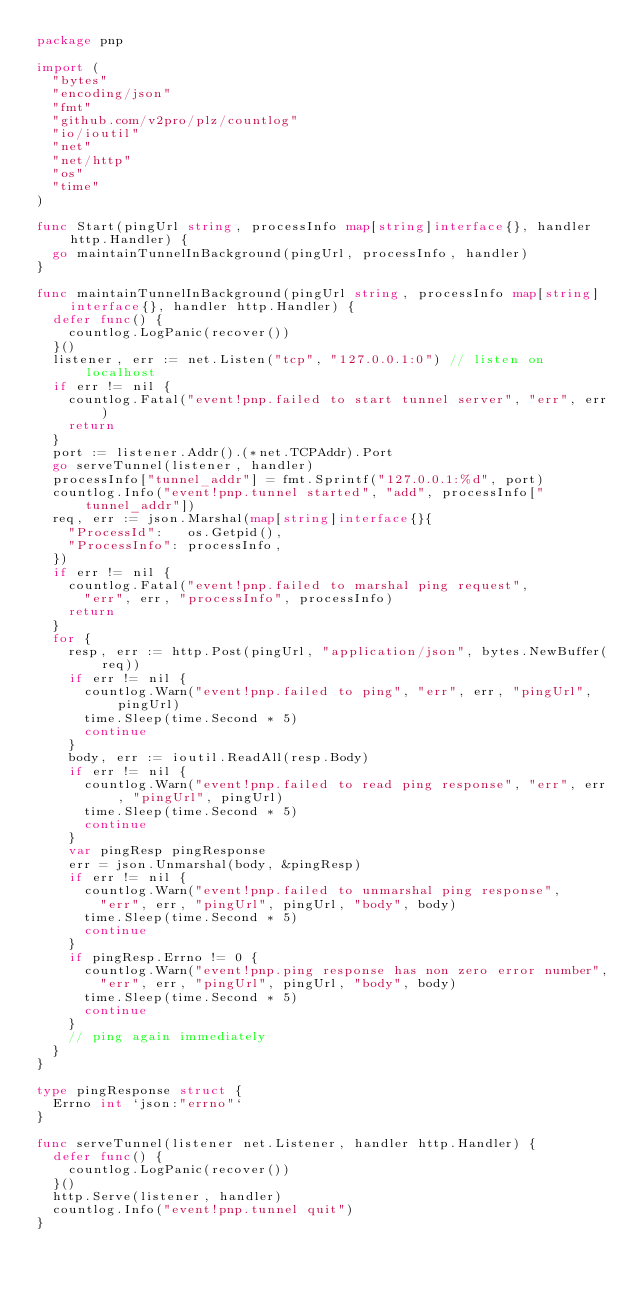Convert code to text. <code><loc_0><loc_0><loc_500><loc_500><_Go_>package pnp

import (
	"bytes"
	"encoding/json"
	"fmt"
	"github.com/v2pro/plz/countlog"
	"io/ioutil"
	"net"
	"net/http"
	"os"
	"time"
)

func Start(pingUrl string, processInfo map[string]interface{}, handler http.Handler) {
	go maintainTunnelInBackground(pingUrl, processInfo, handler)
}

func maintainTunnelInBackground(pingUrl string, processInfo map[string]interface{}, handler http.Handler) {
	defer func() {
		countlog.LogPanic(recover())
	}()
	listener, err := net.Listen("tcp", "127.0.0.1:0") // listen on localhost
	if err != nil {
		countlog.Fatal("event!pnp.failed to start tunnel server", "err", err)
		return
	}
	port := listener.Addr().(*net.TCPAddr).Port
	go serveTunnel(listener, handler)
	processInfo["tunnel_addr"] = fmt.Sprintf("127.0.0.1:%d", port)
	countlog.Info("event!pnp.tunnel started", "add", processInfo["tunnel_addr"])
	req, err := json.Marshal(map[string]interface{}{
		"ProcessId":   os.Getpid(),
		"ProcessInfo": processInfo,
	})
	if err != nil {
		countlog.Fatal("event!pnp.failed to marshal ping request",
			"err", err, "processInfo", processInfo)
		return
	}
	for {
		resp, err := http.Post(pingUrl, "application/json", bytes.NewBuffer(req))
		if err != nil {
			countlog.Warn("event!pnp.failed to ping", "err", err, "pingUrl", pingUrl)
			time.Sleep(time.Second * 5)
			continue
		}
		body, err := ioutil.ReadAll(resp.Body)
		if err != nil {
			countlog.Warn("event!pnp.failed to read ping response", "err", err, "pingUrl", pingUrl)
			time.Sleep(time.Second * 5)
			continue
		}
		var pingResp pingResponse
		err = json.Unmarshal(body, &pingResp)
		if err != nil {
			countlog.Warn("event!pnp.failed to unmarshal ping response",
				"err", err, "pingUrl", pingUrl, "body", body)
			time.Sleep(time.Second * 5)
			continue
		}
		if pingResp.Errno != 0 {
			countlog.Warn("event!pnp.ping response has non zero error number",
				"err", err, "pingUrl", pingUrl, "body", body)
			time.Sleep(time.Second * 5)
			continue
		}
		// ping again immediately
	}
}

type pingResponse struct {
	Errno int `json:"errno"`
}

func serveTunnel(listener net.Listener, handler http.Handler) {
	defer func() {
		countlog.LogPanic(recover())
	}()
	http.Serve(listener, handler)
	countlog.Info("event!pnp.tunnel quit")
}
</code> 